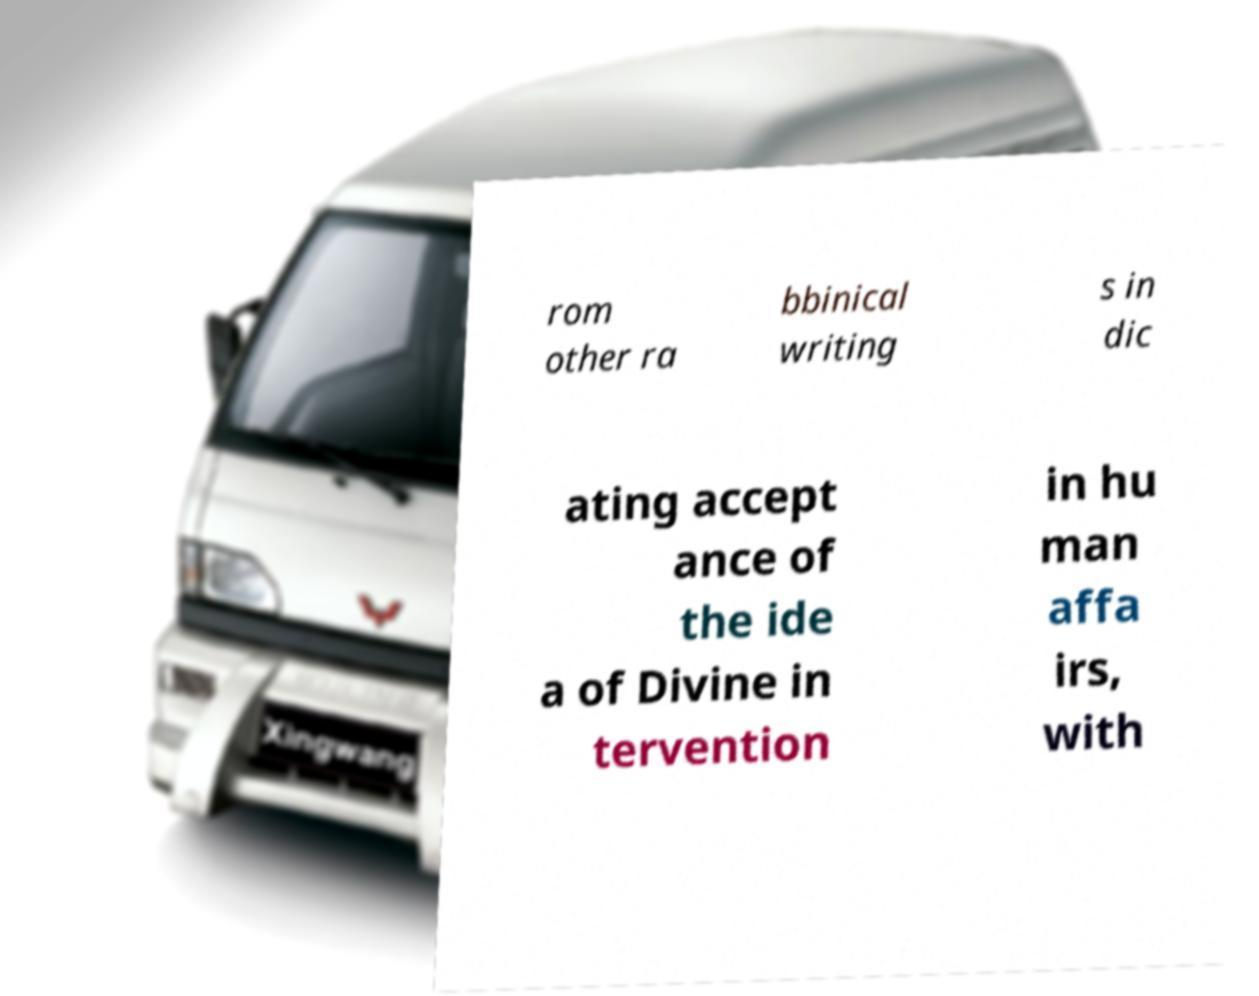Please read and relay the text visible in this image. What does it say? rom other ra bbinical writing s in dic ating accept ance of the ide a of Divine in tervention in hu man affa irs, with 